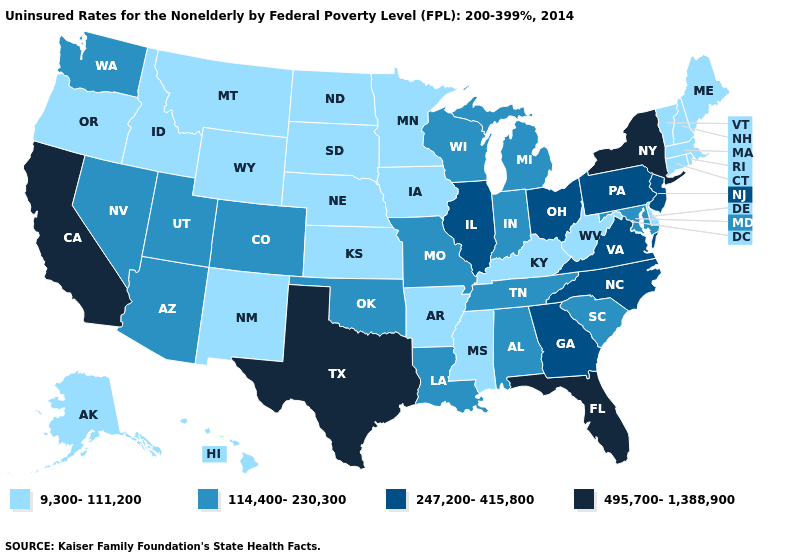What is the value of Massachusetts?
Short answer required. 9,300-111,200. Which states have the lowest value in the USA?
Give a very brief answer. Alaska, Arkansas, Connecticut, Delaware, Hawaii, Idaho, Iowa, Kansas, Kentucky, Maine, Massachusetts, Minnesota, Mississippi, Montana, Nebraska, New Hampshire, New Mexico, North Dakota, Oregon, Rhode Island, South Dakota, Vermont, West Virginia, Wyoming. Which states have the lowest value in the USA?
Quick response, please. Alaska, Arkansas, Connecticut, Delaware, Hawaii, Idaho, Iowa, Kansas, Kentucky, Maine, Massachusetts, Minnesota, Mississippi, Montana, Nebraska, New Hampshire, New Mexico, North Dakota, Oregon, Rhode Island, South Dakota, Vermont, West Virginia, Wyoming. What is the lowest value in the MidWest?
Be succinct. 9,300-111,200. What is the value of Kansas?
Be succinct. 9,300-111,200. What is the highest value in states that border North Dakota?
Keep it brief. 9,300-111,200. How many symbols are there in the legend?
Answer briefly. 4. Among the states that border Oklahoma , does Texas have the highest value?
Keep it brief. Yes. What is the value of Tennessee?
Answer briefly. 114,400-230,300. Which states have the lowest value in the USA?
Be succinct. Alaska, Arkansas, Connecticut, Delaware, Hawaii, Idaho, Iowa, Kansas, Kentucky, Maine, Massachusetts, Minnesota, Mississippi, Montana, Nebraska, New Hampshire, New Mexico, North Dakota, Oregon, Rhode Island, South Dakota, Vermont, West Virginia, Wyoming. What is the highest value in the Northeast ?
Short answer required. 495,700-1,388,900. What is the lowest value in states that border North Dakota?
Answer briefly. 9,300-111,200. Does Idaho have a higher value than Rhode Island?
Concise answer only. No. What is the value of Mississippi?
Quick response, please. 9,300-111,200. Name the states that have a value in the range 9,300-111,200?
Keep it brief. Alaska, Arkansas, Connecticut, Delaware, Hawaii, Idaho, Iowa, Kansas, Kentucky, Maine, Massachusetts, Minnesota, Mississippi, Montana, Nebraska, New Hampshire, New Mexico, North Dakota, Oregon, Rhode Island, South Dakota, Vermont, West Virginia, Wyoming. 